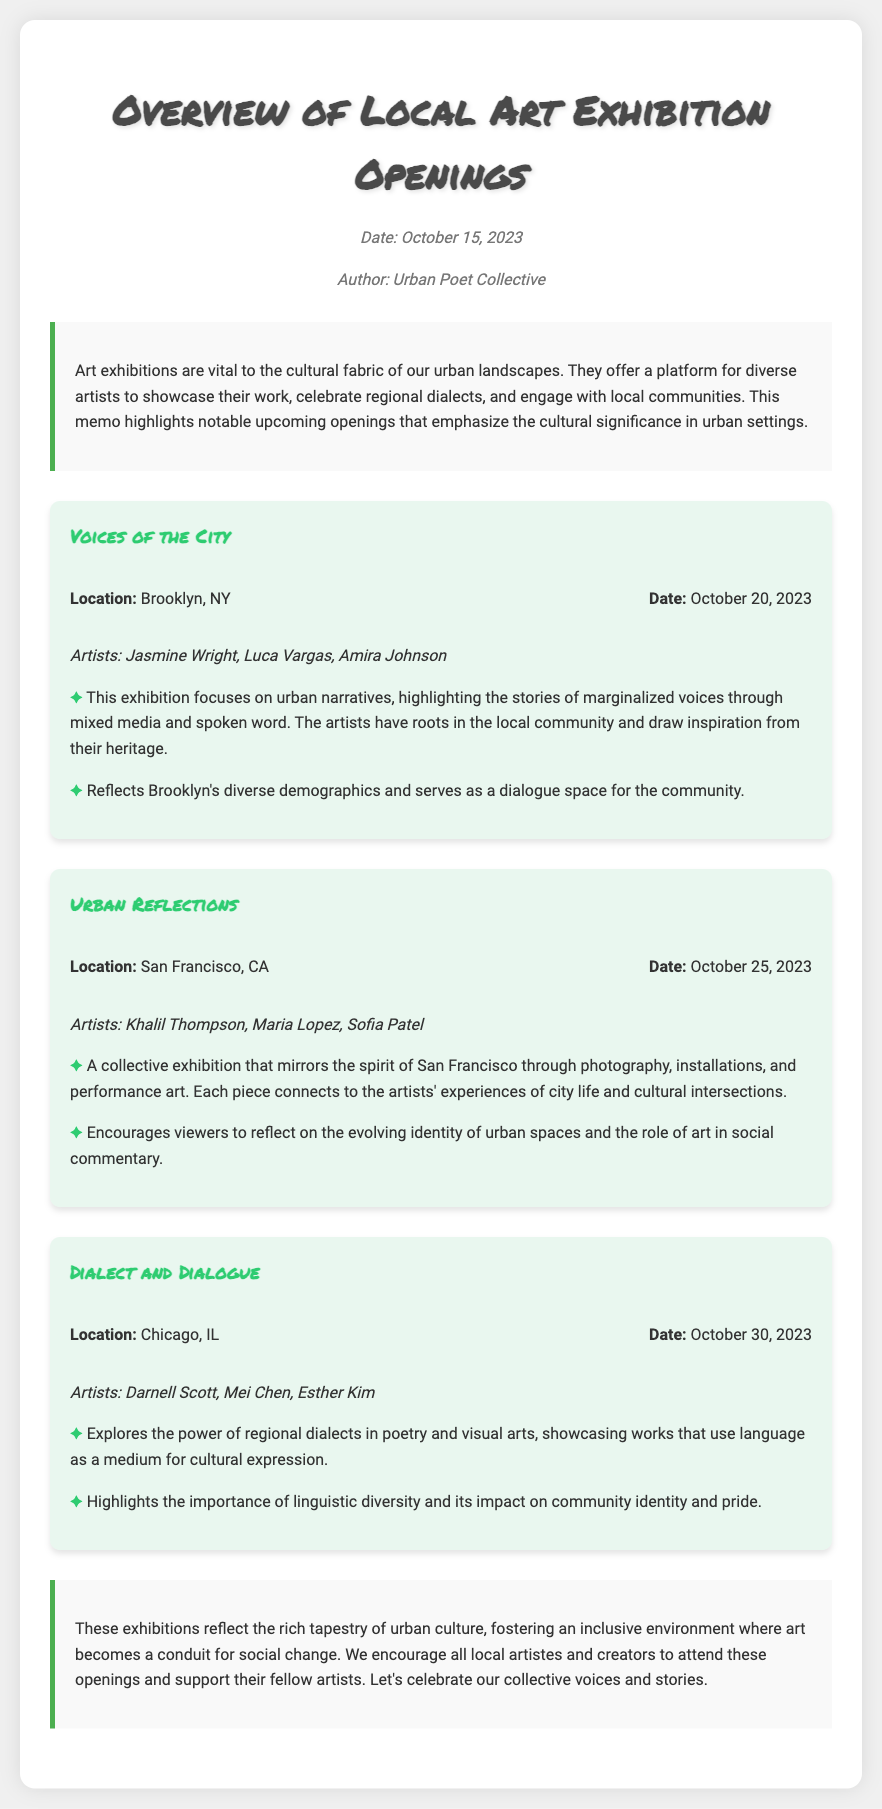what is the title of the first exhibition? The title of the first exhibition is mentioned in the document as "Voices of the City."
Answer: Voices of the City where is the "Urban Reflections" exhibition located? The location of the "Urban Reflections" exhibition is provided in the document as San Francisco, CA.
Answer: San Francisco, CA who are the artists featured in the "Dialect and Dialogue" exhibition? The artists featured in the "Dialect and Dialogue" exhibition include Darnell Scott, Mei Chen, and Esther Kim.
Answer: Darnell Scott, Mei Chen, Esther Kim what is the date of the "Voices of the City" exhibition? The date of the "Voices of the City" exhibition is specified in the document as October 20, 2023.
Answer: October 20, 2023 what cultural aspect does the "Dialect and Dialogue" exhibition highlight? The cultural aspect highlighted by the "Dialect and Dialogue" exhibition is the importance of linguistic diversity and its impact on community identity and pride.
Answer: linguistic diversity why are art exhibitions important in urban settings? Art exhibitions are essential because they offer a platform for diverse artists and engage with local communities, as noted in the introduction.
Answer: engage with local communities what does the theme of the "Urban Reflections" exhibition focus on? The theme of the "Urban Reflections" exhibition focuses on mirroring the spirit of San Francisco through various artistic mediums.
Answer: mirroring the spirit of San Francisco when was the memo written? The memo date is mentioned at the top as October 15, 2023.
Answer: October 15, 2023 what is the conclusion about the role of exhibitions? The conclusion states that exhibitions foster an inclusive environment where art becomes a conduit for social change.
Answer: social change 